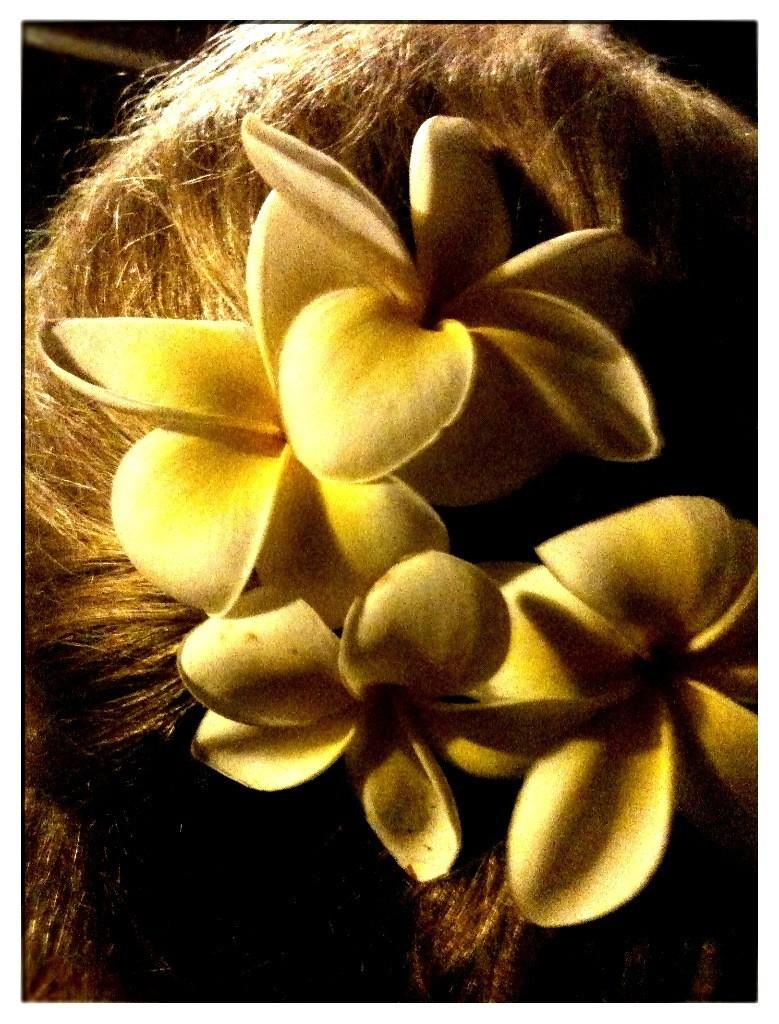What is on the person's hair in the image? There are flowers on the hair in the image. What season is it in the image, given that the flowers are falling? There is no indication in the image that the flowers are falling, and therefore we cannot determine the season. 